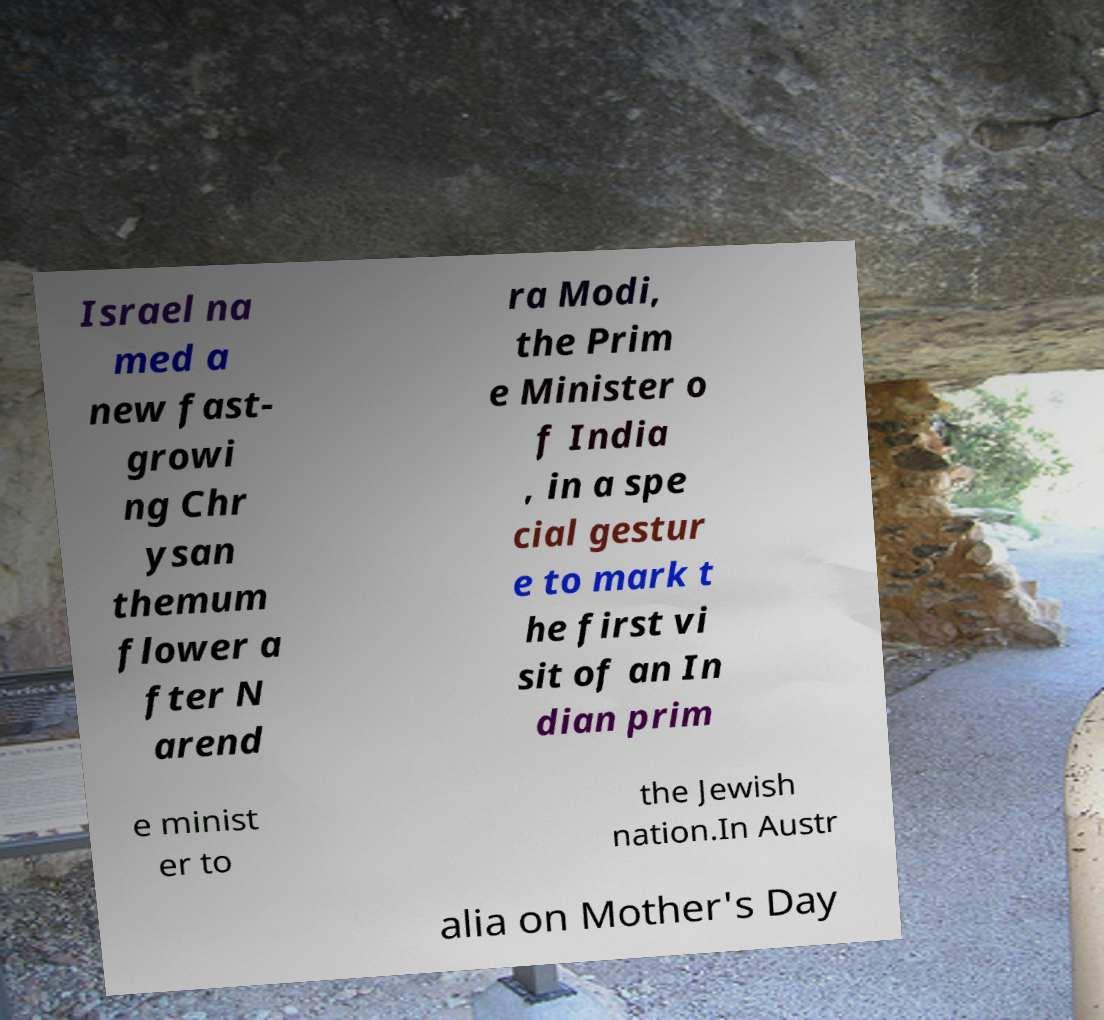There's text embedded in this image that I need extracted. Can you transcribe it verbatim? Israel na med a new fast- growi ng Chr ysan themum flower a fter N arend ra Modi, the Prim e Minister o f India , in a spe cial gestur e to mark t he first vi sit of an In dian prim e minist er to the Jewish nation.In Austr alia on Mother's Day 